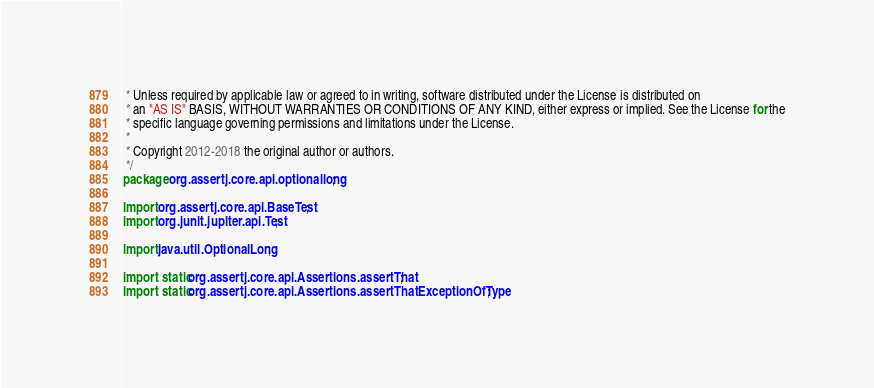Convert code to text. <code><loc_0><loc_0><loc_500><loc_500><_Java_> * Unless required by applicable law or agreed to in writing, software distributed under the License is distributed on
 * an "AS IS" BASIS, WITHOUT WARRANTIES OR CONDITIONS OF ANY KIND, either express or implied. See the License for the
 * specific language governing permissions and limitations under the License.
 *
 * Copyright 2012-2018 the original author or authors.
 */
package org.assertj.core.api.optionallong;

import org.assertj.core.api.BaseTest;
import org.junit.jupiter.api.Test;

import java.util.OptionalLong;

import static org.assertj.core.api.Assertions.assertThat;
import static org.assertj.core.api.Assertions.assertThatExceptionOfType;</code> 